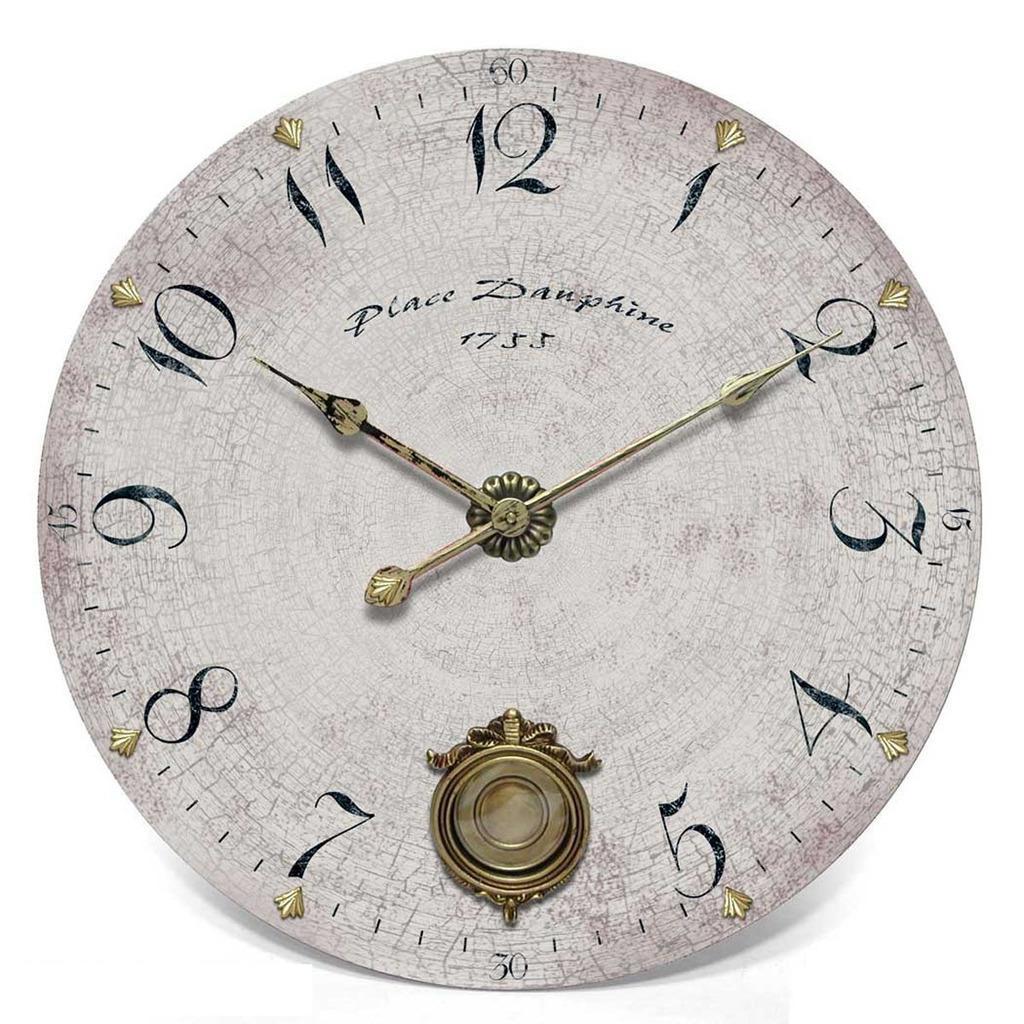Describe this image in one or two sentences. In this image there is a clock. 